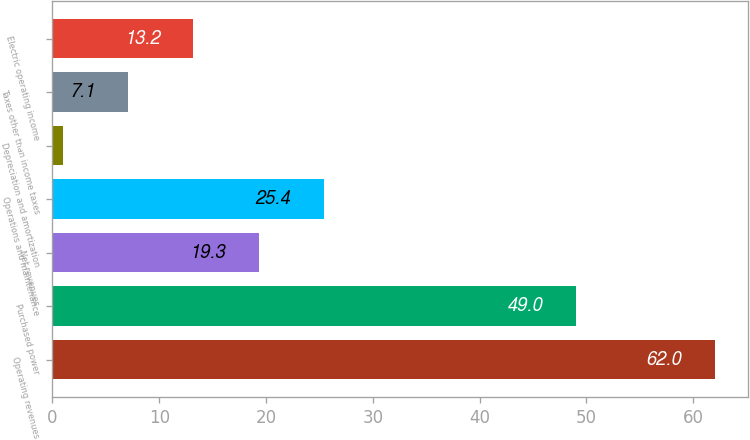<chart> <loc_0><loc_0><loc_500><loc_500><bar_chart><fcel>Operating revenues<fcel>Purchased power<fcel>Net revenues<fcel>Operations and maintenance<fcel>Depreciation and amortization<fcel>Taxes other than income taxes<fcel>Electric operating income<nl><fcel>62<fcel>49<fcel>19.3<fcel>25.4<fcel>1<fcel>7.1<fcel>13.2<nl></chart> 